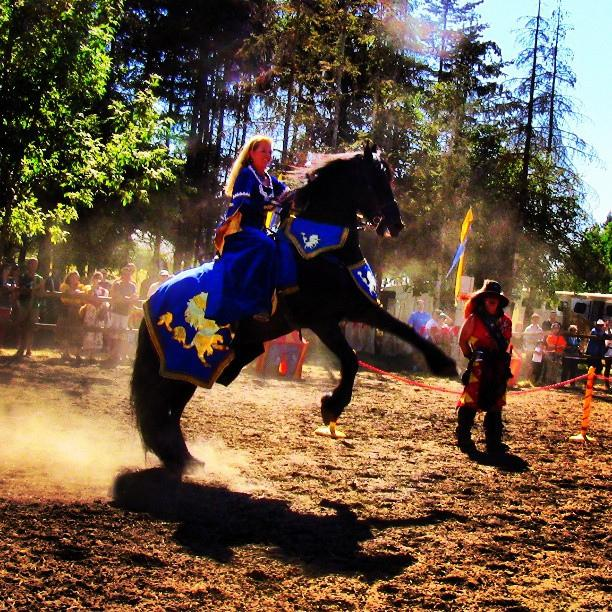What attire is the person standing behind the horse in front of the red rope wearing? Please explain your reasoning. native american. The man is seen wearing the cap that was used in those area. 